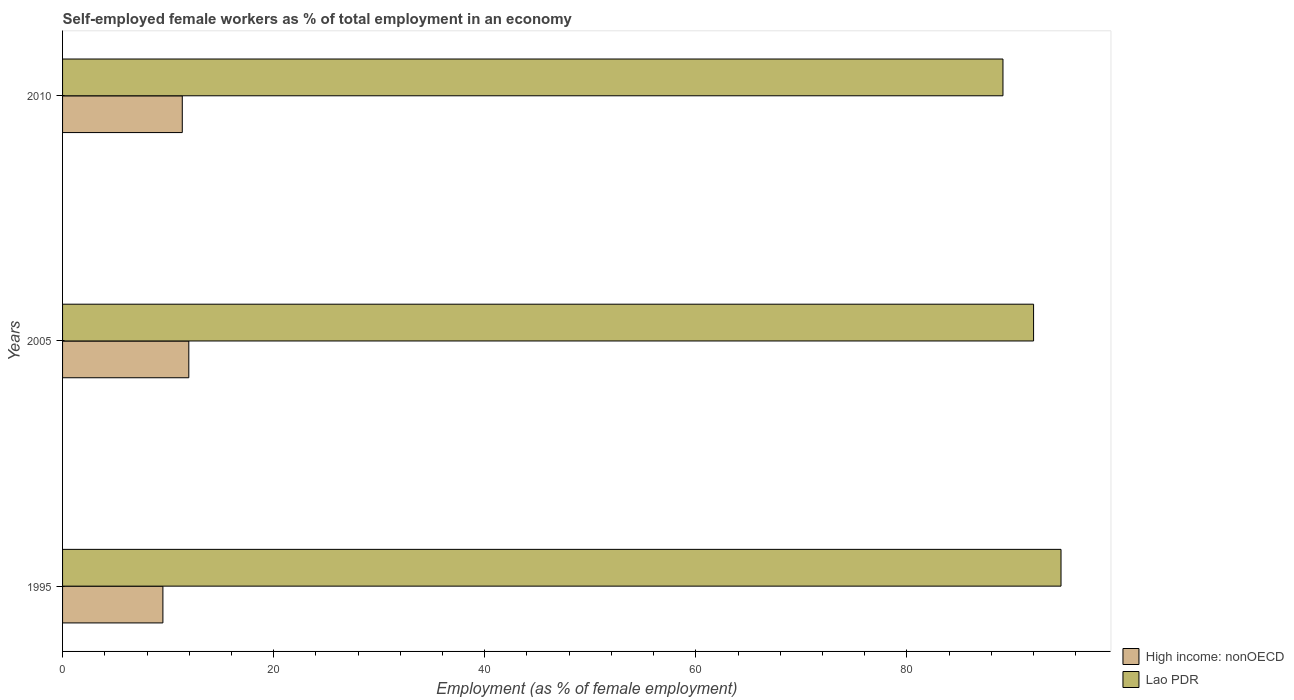How many groups of bars are there?
Your response must be concise. 3. Are the number of bars per tick equal to the number of legend labels?
Provide a short and direct response. Yes. Are the number of bars on each tick of the Y-axis equal?
Offer a very short reply. Yes. How many bars are there on the 1st tick from the bottom?
Offer a very short reply. 2. What is the percentage of self-employed female workers in Lao PDR in 2010?
Your response must be concise. 89.1. Across all years, what is the maximum percentage of self-employed female workers in Lao PDR?
Your response must be concise. 94.6. Across all years, what is the minimum percentage of self-employed female workers in High income: nonOECD?
Ensure brevity in your answer.  9.51. In which year was the percentage of self-employed female workers in Lao PDR minimum?
Offer a terse response. 2010. What is the total percentage of self-employed female workers in Lao PDR in the graph?
Offer a terse response. 275.7. What is the difference between the percentage of self-employed female workers in High income: nonOECD in 1995 and that in 2010?
Offer a terse response. -1.84. What is the difference between the percentage of self-employed female workers in Lao PDR in 2005 and the percentage of self-employed female workers in High income: nonOECD in 1995?
Keep it short and to the point. 82.49. What is the average percentage of self-employed female workers in Lao PDR per year?
Keep it short and to the point. 91.9. In the year 2005, what is the difference between the percentage of self-employed female workers in Lao PDR and percentage of self-employed female workers in High income: nonOECD?
Make the answer very short. 80.04. What is the ratio of the percentage of self-employed female workers in High income: nonOECD in 2005 to that in 2010?
Offer a very short reply. 1.05. Is the difference between the percentage of self-employed female workers in Lao PDR in 1995 and 2010 greater than the difference between the percentage of self-employed female workers in High income: nonOECD in 1995 and 2010?
Give a very brief answer. Yes. What is the difference between the highest and the second highest percentage of self-employed female workers in High income: nonOECD?
Keep it short and to the point. 0.62. What is the difference between the highest and the lowest percentage of self-employed female workers in Lao PDR?
Your answer should be very brief. 5.5. In how many years, is the percentage of self-employed female workers in High income: nonOECD greater than the average percentage of self-employed female workers in High income: nonOECD taken over all years?
Provide a short and direct response. 2. Is the sum of the percentage of self-employed female workers in High income: nonOECD in 2005 and 2010 greater than the maximum percentage of self-employed female workers in Lao PDR across all years?
Your answer should be compact. No. What does the 1st bar from the top in 2005 represents?
Provide a short and direct response. Lao PDR. What does the 2nd bar from the bottom in 1995 represents?
Keep it short and to the point. Lao PDR. How many bars are there?
Give a very brief answer. 6. Are all the bars in the graph horizontal?
Ensure brevity in your answer.  Yes. Are the values on the major ticks of X-axis written in scientific E-notation?
Make the answer very short. No. Does the graph contain any zero values?
Give a very brief answer. No. Where does the legend appear in the graph?
Offer a very short reply. Bottom right. How are the legend labels stacked?
Make the answer very short. Vertical. What is the title of the graph?
Give a very brief answer. Self-employed female workers as % of total employment in an economy. What is the label or title of the X-axis?
Your response must be concise. Employment (as % of female employment). What is the label or title of the Y-axis?
Provide a short and direct response. Years. What is the Employment (as % of female employment) of High income: nonOECD in 1995?
Provide a short and direct response. 9.51. What is the Employment (as % of female employment) of Lao PDR in 1995?
Provide a short and direct response. 94.6. What is the Employment (as % of female employment) in High income: nonOECD in 2005?
Ensure brevity in your answer.  11.96. What is the Employment (as % of female employment) in Lao PDR in 2005?
Give a very brief answer. 92. What is the Employment (as % of female employment) of High income: nonOECD in 2010?
Your answer should be compact. 11.34. What is the Employment (as % of female employment) of Lao PDR in 2010?
Your response must be concise. 89.1. Across all years, what is the maximum Employment (as % of female employment) of High income: nonOECD?
Ensure brevity in your answer.  11.96. Across all years, what is the maximum Employment (as % of female employment) in Lao PDR?
Your answer should be very brief. 94.6. Across all years, what is the minimum Employment (as % of female employment) of High income: nonOECD?
Your answer should be compact. 9.51. Across all years, what is the minimum Employment (as % of female employment) in Lao PDR?
Provide a succinct answer. 89.1. What is the total Employment (as % of female employment) in High income: nonOECD in the graph?
Provide a short and direct response. 32.81. What is the total Employment (as % of female employment) in Lao PDR in the graph?
Your response must be concise. 275.7. What is the difference between the Employment (as % of female employment) in High income: nonOECD in 1995 and that in 2005?
Offer a very short reply. -2.45. What is the difference between the Employment (as % of female employment) in Lao PDR in 1995 and that in 2005?
Your answer should be very brief. 2.6. What is the difference between the Employment (as % of female employment) of High income: nonOECD in 1995 and that in 2010?
Provide a short and direct response. -1.84. What is the difference between the Employment (as % of female employment) in Lao PDR in 1995 and that in 2010?
Give a very brief answer. 5.5. What is the difference between the Employment (as % of female employment) in High income: nonOECD in 2005 and that in 2010?
Your response must be concise. 0.62. What is the difference between the Employment (as % of female employment) in High income: nonOECD in 1995 and the Employment (as % of female employment) in Lao PDR in 2005?
Offer a terse response. -82.49. What is the difference between the Employment (as % of female employment) of High income: nonOECD in 1995 and the Employment (as % of female employment) of Lao PDR in 2010?
Ensure brevity in your answer.  -79.59. What is the difference between the Employment (as % of female employment) in High income: nonOECD in 2005 and the Employment (as % of female employment) in Lao PDR in 2010?
Keep it short and to the point. -77.14. What is the average Employment (as % of female employment) in High income: nonOECD per year?
Offer a very short reply. 10.94. What is the average Employment (as % of female employment) in Lao PDR per year?
Your response must be concise. 91.9. In the year 1995, what is the difference between the Employment (as % of female employment) of High income: nonOECD and Employment (as % of female employment) of Lao PDR?
Ensure brevity in your answer.  -85.09. In the year 2005, what is the difference between the Employment (as % of female employment) in High income: nonOECD and Employment (as % of female employment) in Lao PDR?
Give a very brief answer. -80.04. In the year 2010, what is the difference between the Employment (as % of female employment) of High income: nonOECD and Employment (as % of female employment) of Lao PDR?
Offer a very short reply. -77.76. What is the ratio of the Employment (as % of female employment) in High income: nonOECD in 1995 to that in 2005?
Your response must be concise. 0.79. What is the ratio of the Employment (as % of female employment) of Lao PDR in 1995 to that in 2005?
Ensure brevity in your answer.  1.03. What is the ratio of the Employment (as % of female employment) of High income: nonOECD in 1995 to that in 2010?
Your response must be concise. 0.84. What is the ratio of the Employment (as % of female employment) in Lao PDR in 1995 to that in 2010?
Make the answer very short. 1.06. What is the ratio of the Employment (as % of female employment) in High income: nonOECD in 2005 to that in 2010?
Provide a short and direct response. 1.05. What is the ratio of the Employment (as % of female employment) of Lao PDR in 2005 to that in 2010?
Provide a succinct answer. 1.03. What is the difference between the highest and the second highest Employment (as % of female employment) of High income: nonOECD?
Provide a succinct answer. 0.62. What is the difference between the highest and the second highest Employment (as % of female employment) of Lao PDR?
Provide a succinct answer. 2.6. What is the difference between the highest and the lowest Employment (as % of female employment) of High income: nonOECD?
Offer a terse response. 2.45. 